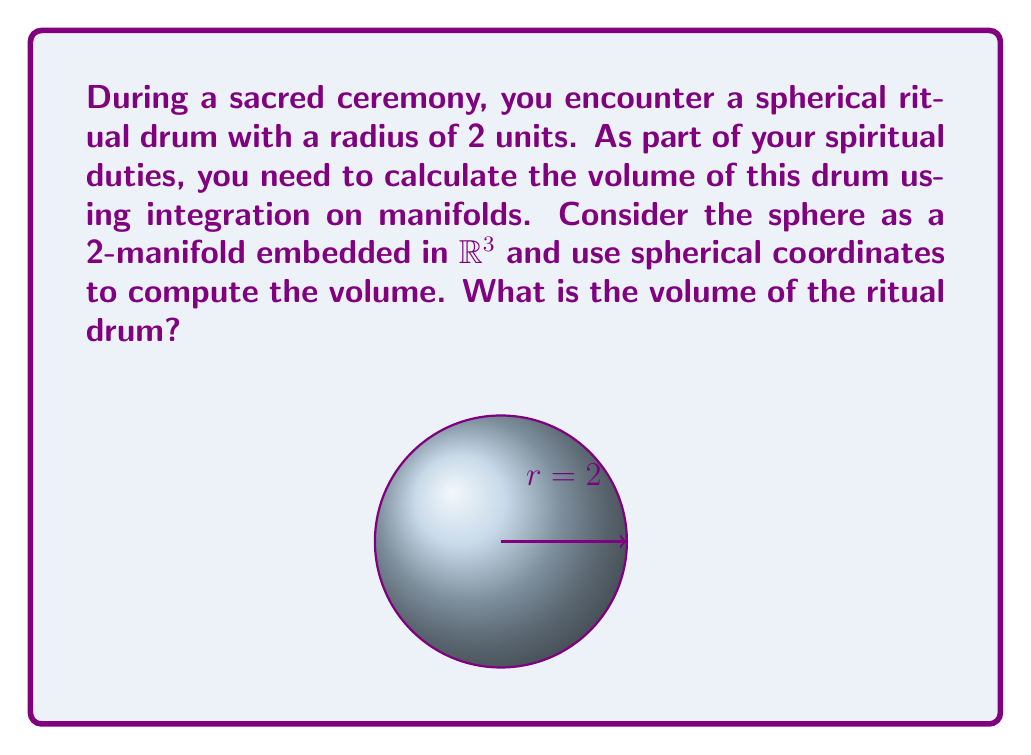Show me your answer to this math problem. To compute the volume of the spherical ritual drum using integration on manifolds, we'll follow these steps:

1) In spherical coordinates, a point on the sphere is given by:
   $x = r\sin\theta\cos\phi$
   $y = r\sin\theta\sin\phi$
   $z = r\cos\theta$
   where $0 \leq r \leq 2$, $0 \leq \theta \leq \pi$, and $0 \leq \phi \leq 2\pi$

2) The volume element in spherical coordinates is:
   $dV = r^2 \sin\theta \, dr \, d\theta \, d\phi$

3) The volume is given by the triple integral:
   $$V = \int_0^{2\pi} \int_0^{\pi} \int_0^2 r^2 \sin\theta \, dr \, d\theta \, d\phi$$

4) Integrate with respect to $r$:
   $$V = \int_0^{2\pi} \int_0^{\pi} \left[\frac{1}{3}r^3\right]_0^2 \sin\theta \, d\theta \, d\phi = \frac{8}{3} \int_0^{2\pi} \int_0^{\pi} \sin\theta \, d\theta \, d\phi$$

5) Integrate with respect to $\theta$:
   $$V = \frac{8}{3} \int_0^{2\pi} \left[-\cos\theta\right]_0^{\pi} \, d\phi = \frac{16}{3} \int_0^{2\pi} \, d\phi$$

6) Finally, integrate with respect to $\phi$:
   $$V = \frac{16}{3} \left[\phi\right]_0^{2\pi} = \frac{32\pi}{3}$$

Thus, the volume of the spherical ritual drum is $\frac{32\pi}{3}$ cubic units.
Answer: $\frac{32\pi}{3}$ cubic units 